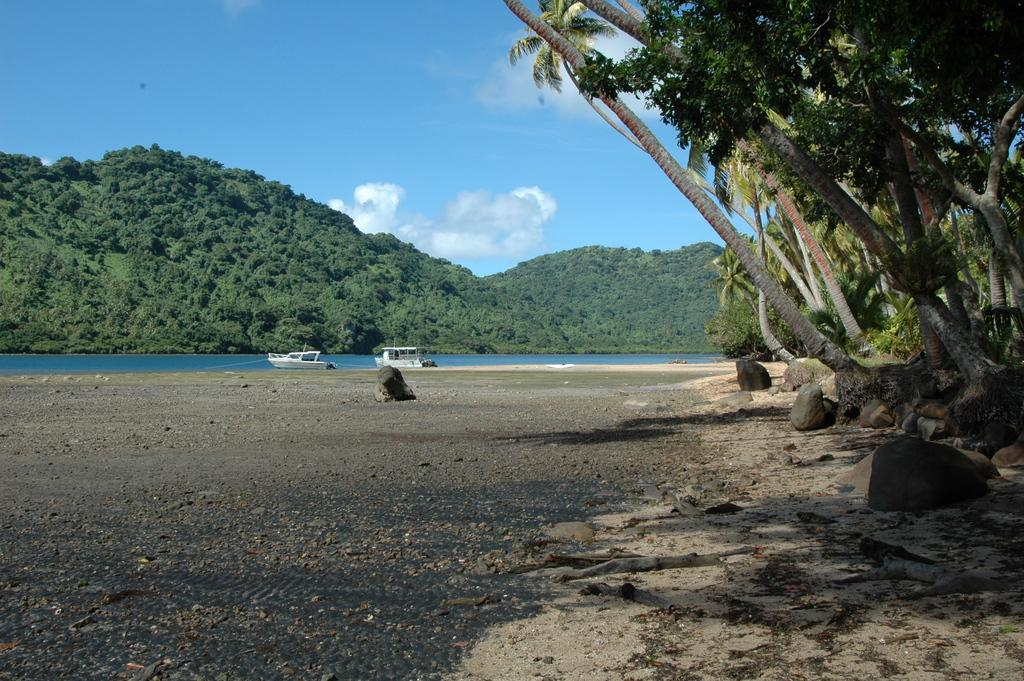What type of natural elements can be seen in the image? There are many rocks, trees, and water visible in the image. Can you describe the boats in the image? There are two boats on the water in the background of the image. What is visible in the background of the image? There are many trees, mountains, clouds, and the sky visible in the background. What type of dress is being woven with the thread in the image? There is no dress or thread present in the image; it features natural elements and boats. How does the harmony between the rocks and trees contribute to the overall aesthetic of the image? The image does not specifically mention harmony between the rocks and trees, but the combination of these natural elements creates a visually appealing scene. 